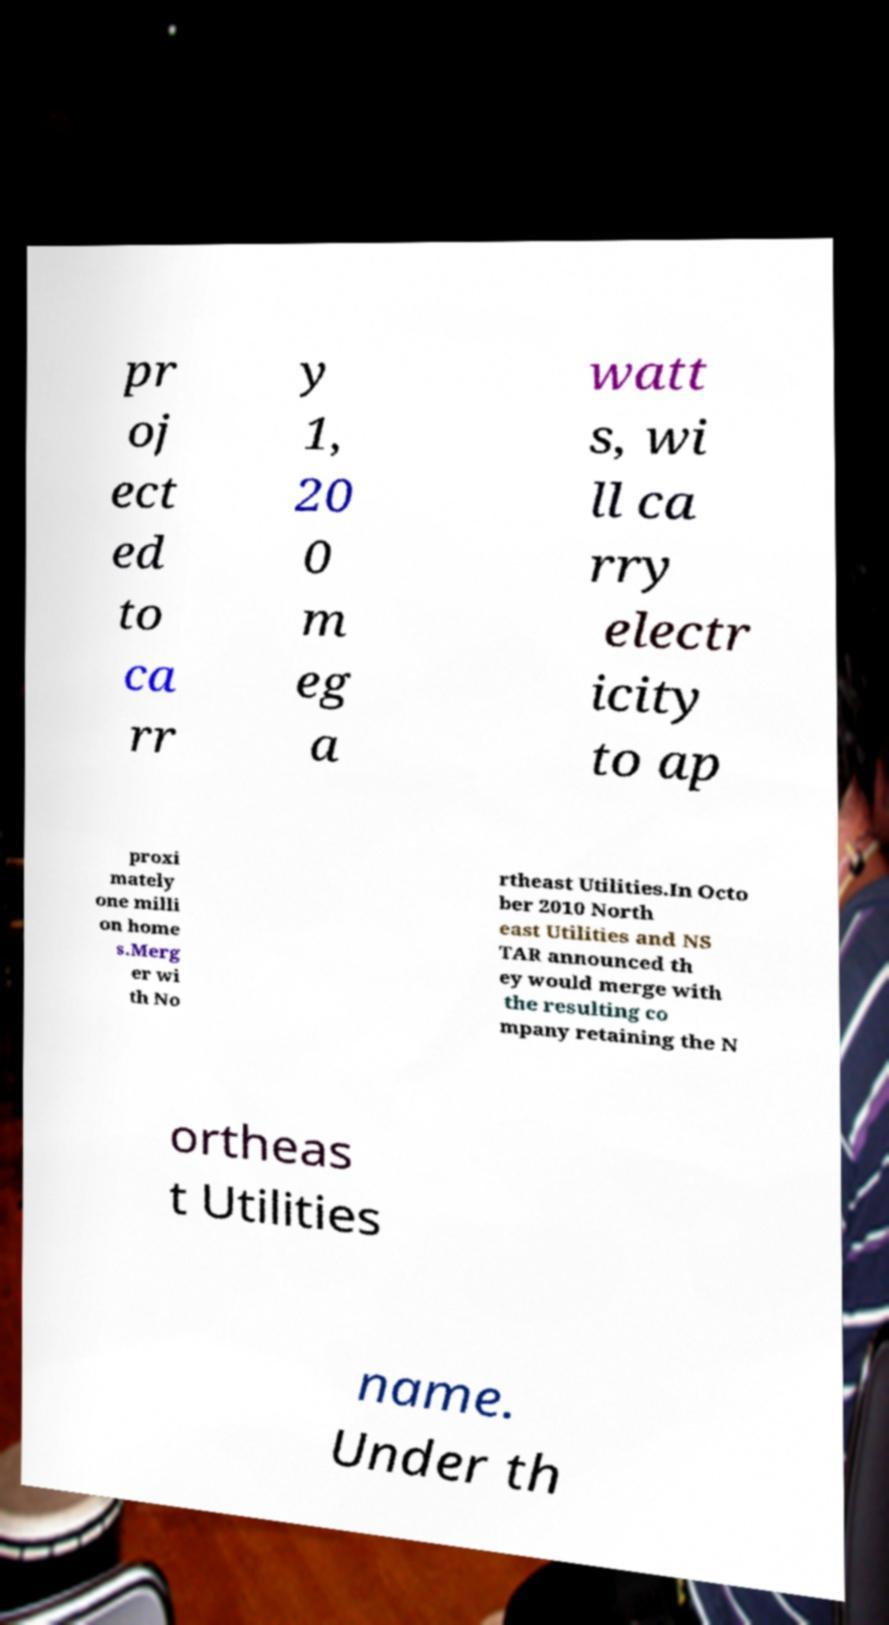Could you extract and type out the text from this image? pr oj ect ed to ca rr y 1, 20 0 m eg a watt s, wi ll ca rry electr icity to ap proxi mately one milli on home s.Merg er wi th No rtheast Utilities.In Octo ber 2010 North east Utilities and NS TAR announced th ey would merge with the resulting co mpany retaining the N ortheas t Utilities name. Under th 